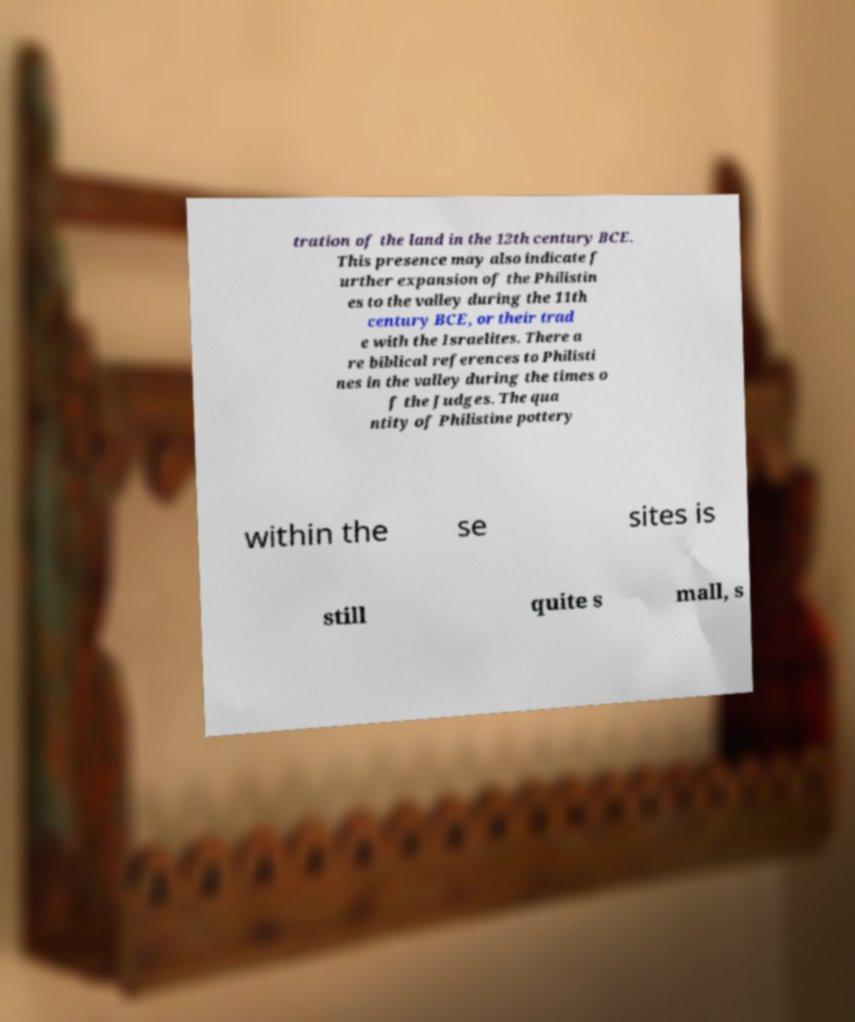I need the written content from this picture converted into text. Can you do that? tration of the land in the 12th century BCE. This presence may also indicate f urther expansion of the Philistin es to the valley during the 11th century BCE, or their trad e with the Israelites. There a re biblical references to Philisti nes in the valley during the times o f the Judges. The qua ntity of Philistine pottery within the se sites is still quite s mall, s 